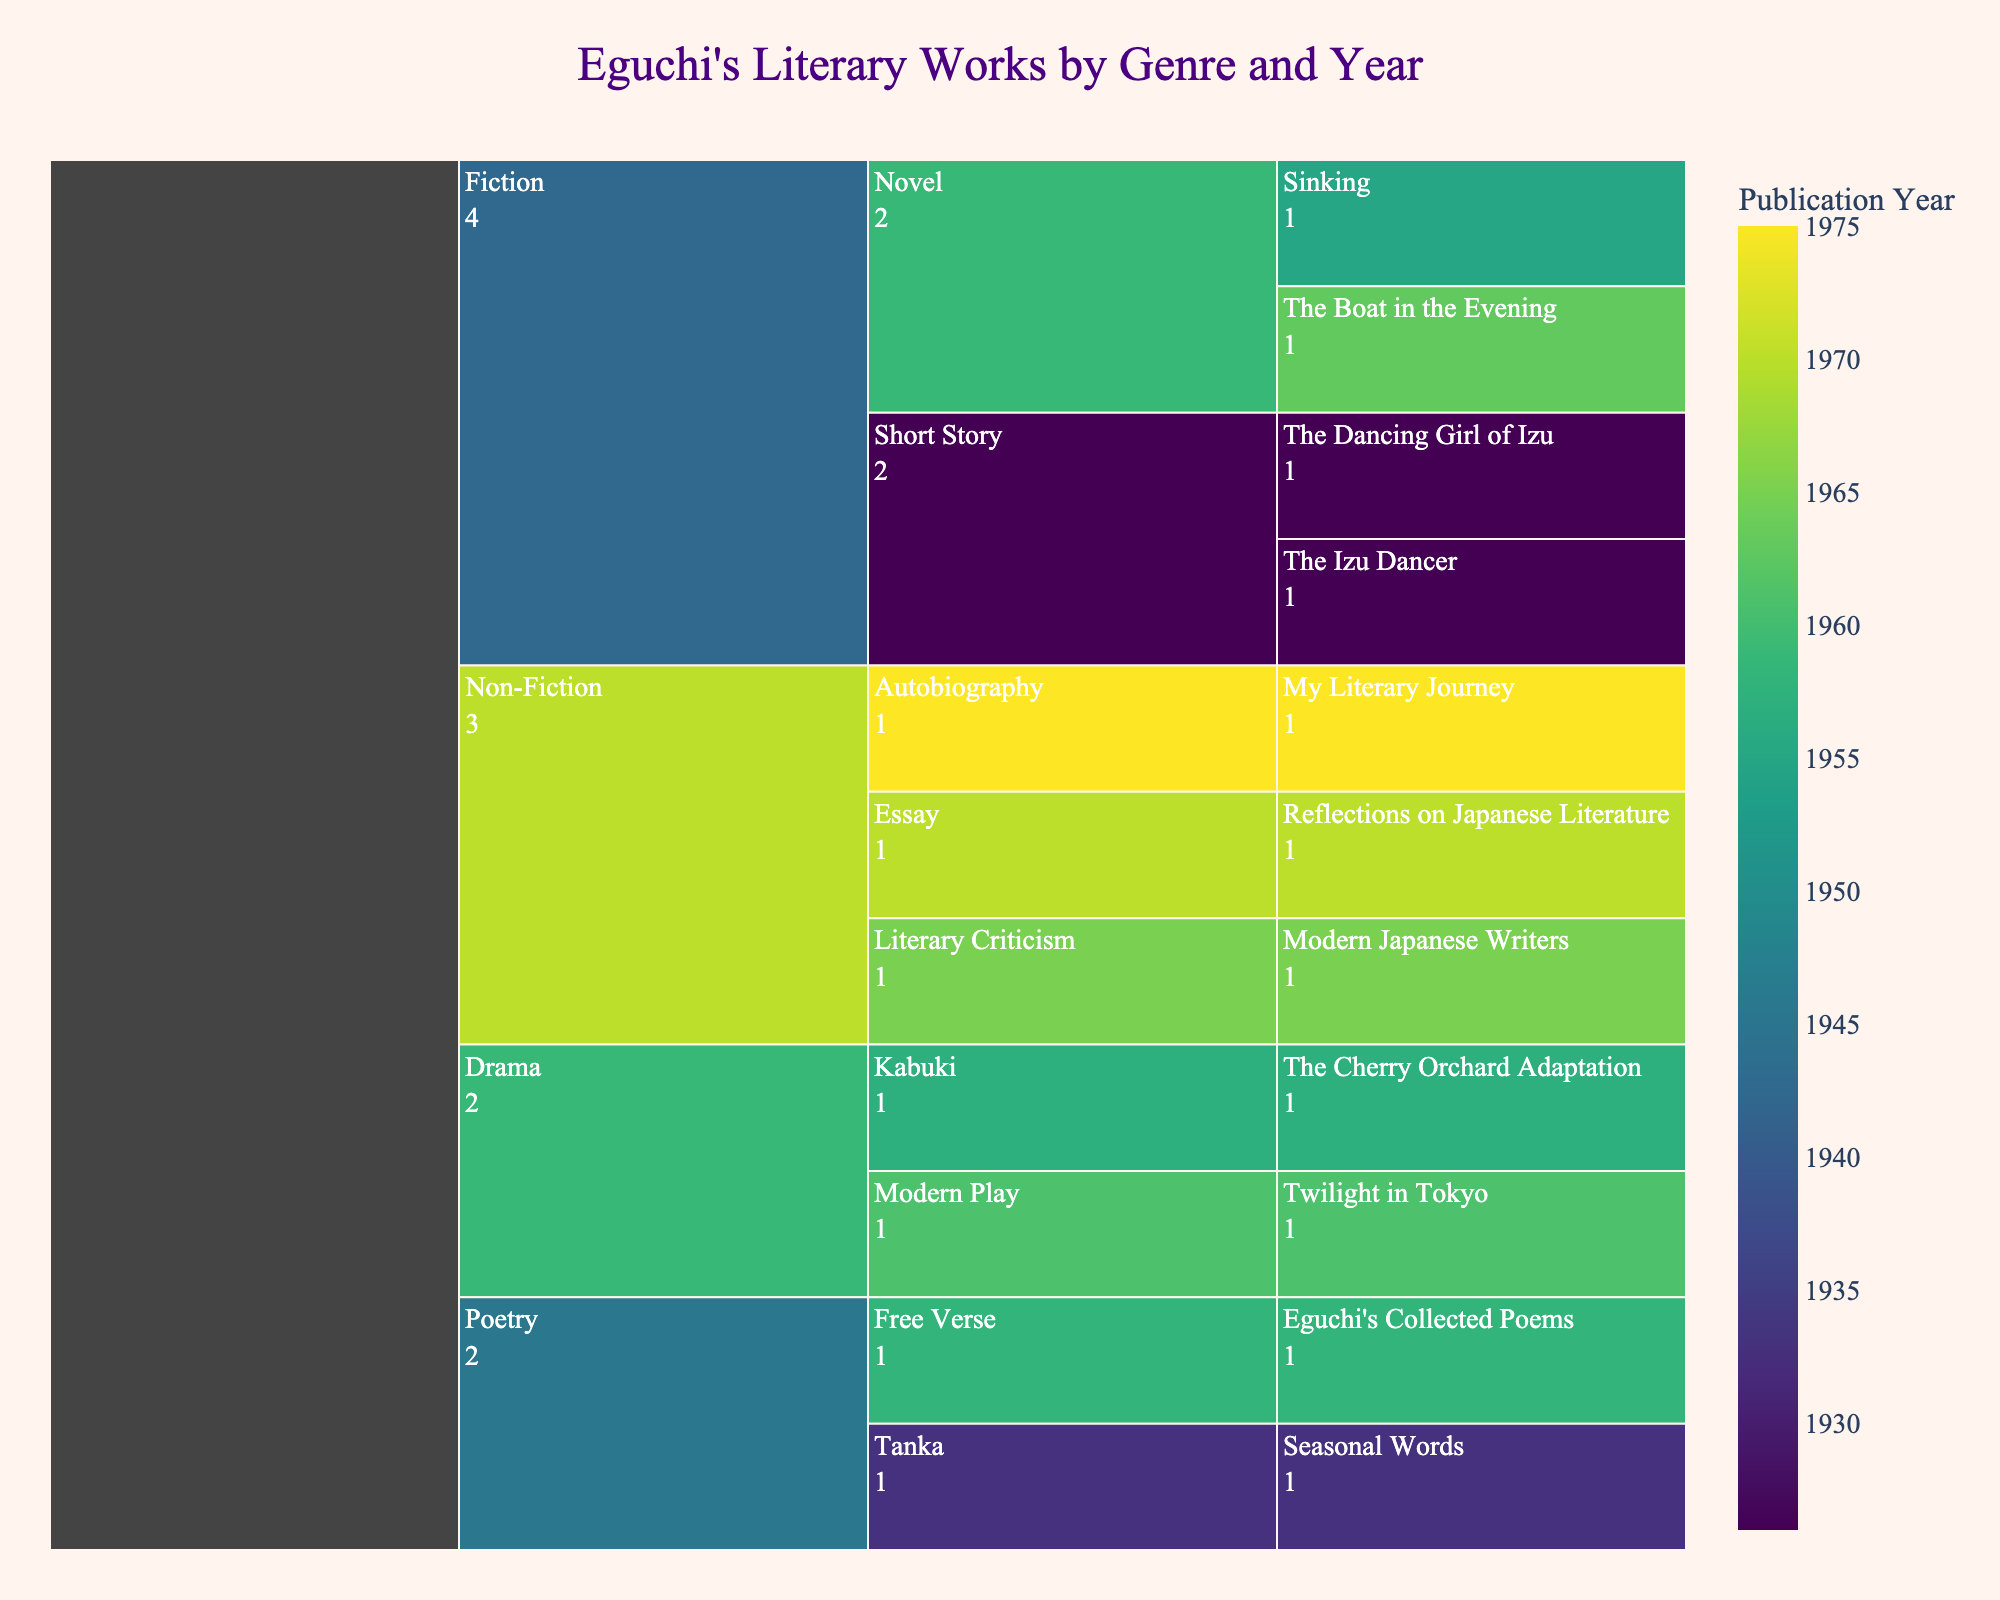How many works are represented in the Fiction genre? The Icicle chart organizes the data by genre first. By counting the total number of works under the Fiction genre segment, which includes both Novels and Short Stories, we get the total number of works. The Fiction segment includes "The Boat in the Evening," "Sinking," "The Dancing Girl of Izu," and "The Izu Dancer." Thus, there are four works listed.
Answer: Four Which genres have works that were published in the 1950s? The color of the sections represents the publication year. By looking at the color bar corresponding to the 1950s, and then identifying the genres where these color segments appear, we can find the relevant genres. These genres are Fiction ("Sinking"), Poetry ("Eguchi's Collected Poems"), and Drama ("The Cherry Orchard Adaptation").
Answer: Fiction, Poetry, Drama What is the earliest published work across all genres? By identifying the section with the color corresponding to the earliest year and checking its label, we find that "The Dancing Girl of Izu" and "The Izu Dancer" were both published in 1926, which is the earliest year shown in the chart.
Answer: The Dancing Girl of Izu, The Izu Dancer Which genre has the most subgenres and what are they? In the Icicle chart, each genre expands into subgenres. By counting the number of subcategories under each genre, we can determine that Non-Fiction has the most subgenres: including Essay, Literary Criticism, Autobiography.
Answer: Non-Fiction, Essay, Literary Criticism, Autobiography How many works in total are there in Drama? By counting each work labeled under the Drama genre in the chart, we find there are two works: "The Cherry Orchard Adaptation" and "Twilight in Tokyo."
Answer: Two Which genre and subgenre combination has the latest published work? First, we need to identify the color corresponding to the latest year on the color scale. Then, by finding the genre and subgenre under this color, we locate "My Literary Journey" under Non-Fiction and Autobiography as the latest work, published in 1975.
Answer: Non-Fiction, Autobiography What percentage of the Fiction genre does the Novel subgenre constitute? The Fiction genre has four works in total, including two Novels ("The Boat in the Evening" and "Sinking"). To find the percentage, use the formula (Number of Novels / Total Fiction Works) * 100. This gives (2/4) * 100 = 50%.
Answer: 50% How many genres are represented in the dataset? The top level of the Icicle chart shows the genres, each represented by a distinct segment. By counting these segments, we identify four genres: Fiction, Poetry, Non-Fiction, and Drama.
Answer: Four Which work has the smallest segment, and why might this be the case? Assuming all works have equal value (as each segment is of value 1), each work will have equally sized segments. However, the Icicle chart might visually appear to differ due to layout organization. Analyze the data further: by structure and display, no work inherently has a smaller segment.
Answer: All works have equal segments What is the second most frequent subgenre under Non-Fiction? Under Non-Fiction, counting the works per subgenre reveals that Essay ("Reflections on Japanese Literature"), Literary Criticism ("Modern Japanese Writers"), and Autobiography ("My Literary Journey") have one work each. Since all subgenres are equally frequent, selecting any one as the second most frequent is valid.
Answer: Literary Criticism (or any other, as they are equal) 